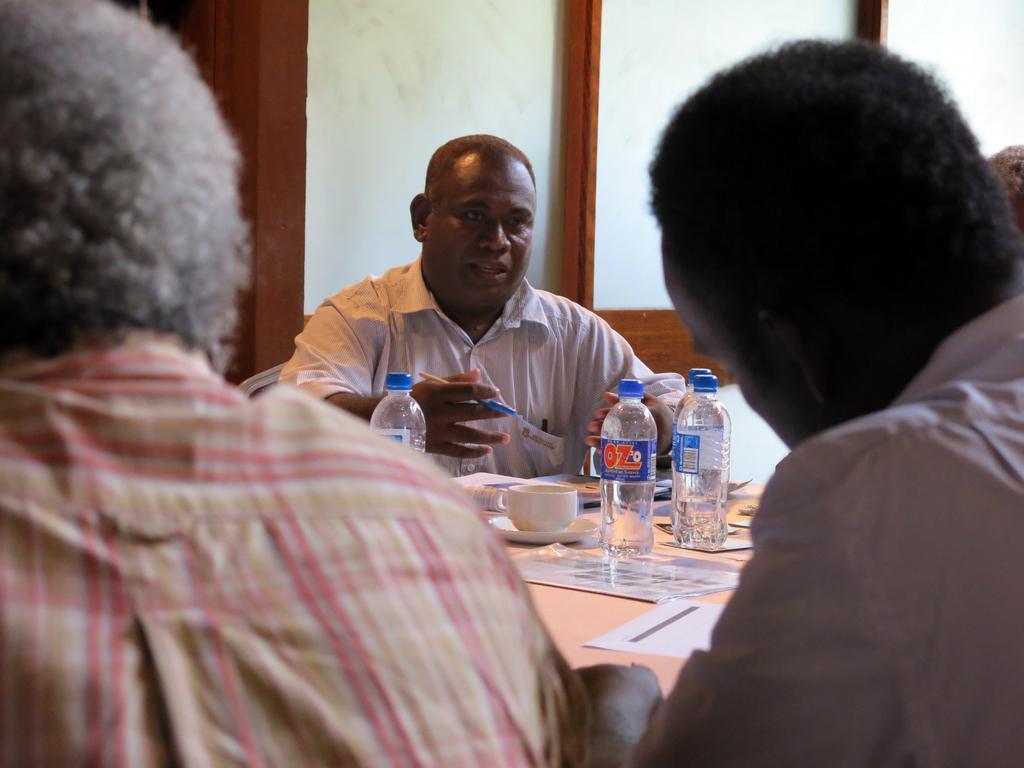Can you describe this image briefly? This image is taken in a room. There are three people in a room, they are men. In the middle a man is wearing a white colored shirt holding a pen in his hand. There is table in the middle, there are three bottles on the table, a cup and saucer and a papers. The man in the middle is sitting on a chair. 